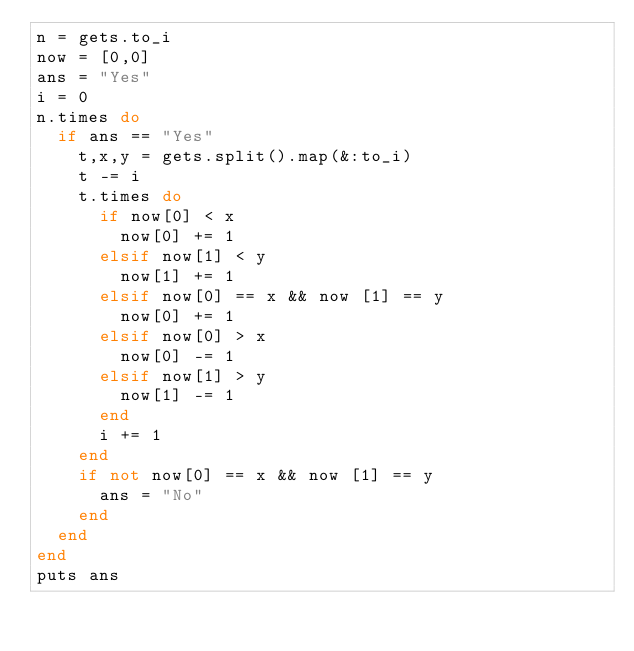Convert code to text. <code><loc_0><loc_0><loc_500><loc_500><_Ruby_>n = gets.to_i
now = [0,0]
ans = "Yes"
i = 0
n.times do
  if ans == "Yes"
    t,x,y = gets.split().map(&:to_i)
    t -= i
    t.times do
      if now[0] < x
        now[0] += 1
      elsif now[1] < y
        now[1] += 1
      elsif now[0] == x && now [1] == y
        now[0] += 1
      elsif now[0] > x
        now[0] -= 1
      elsif now[1] > y
        now[1] -= 1
      end
      i += 1
    end
    if not now[0] == x && now [1] == y
      ans = "No"
    end
  end
end
puts ans</code> 